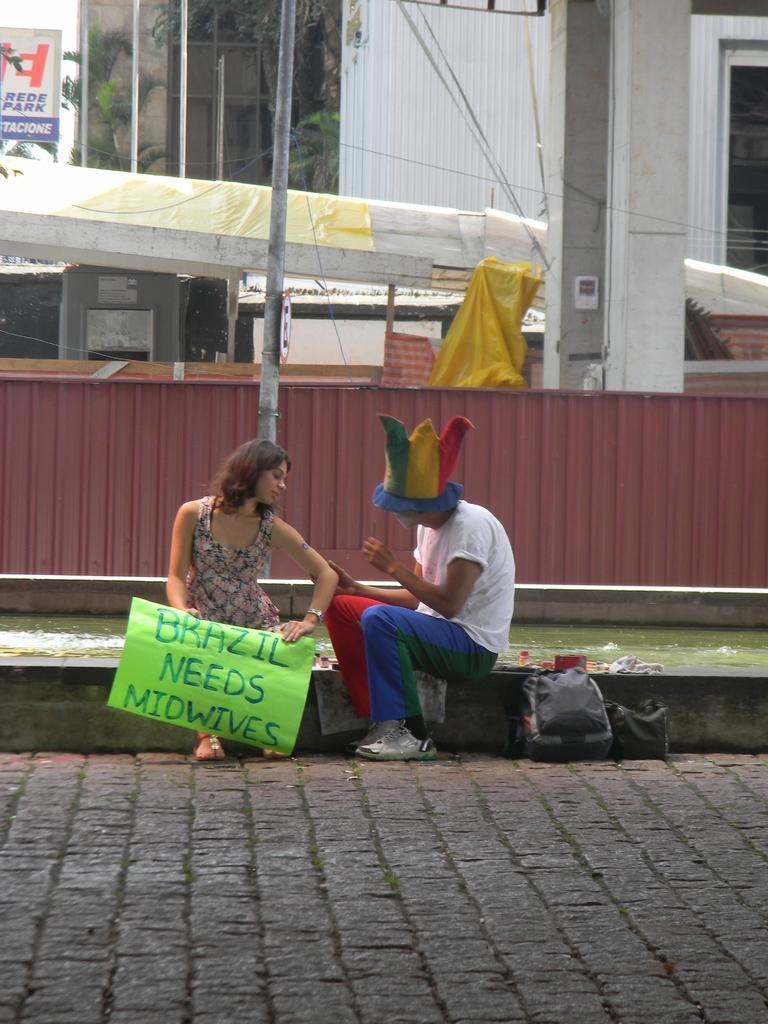Could you give a brief overview of what you see in this image? In this picture I can see a man and a woman in the middle, this woman is holding the placard with her hands, in the background there are boards, building and trees. 